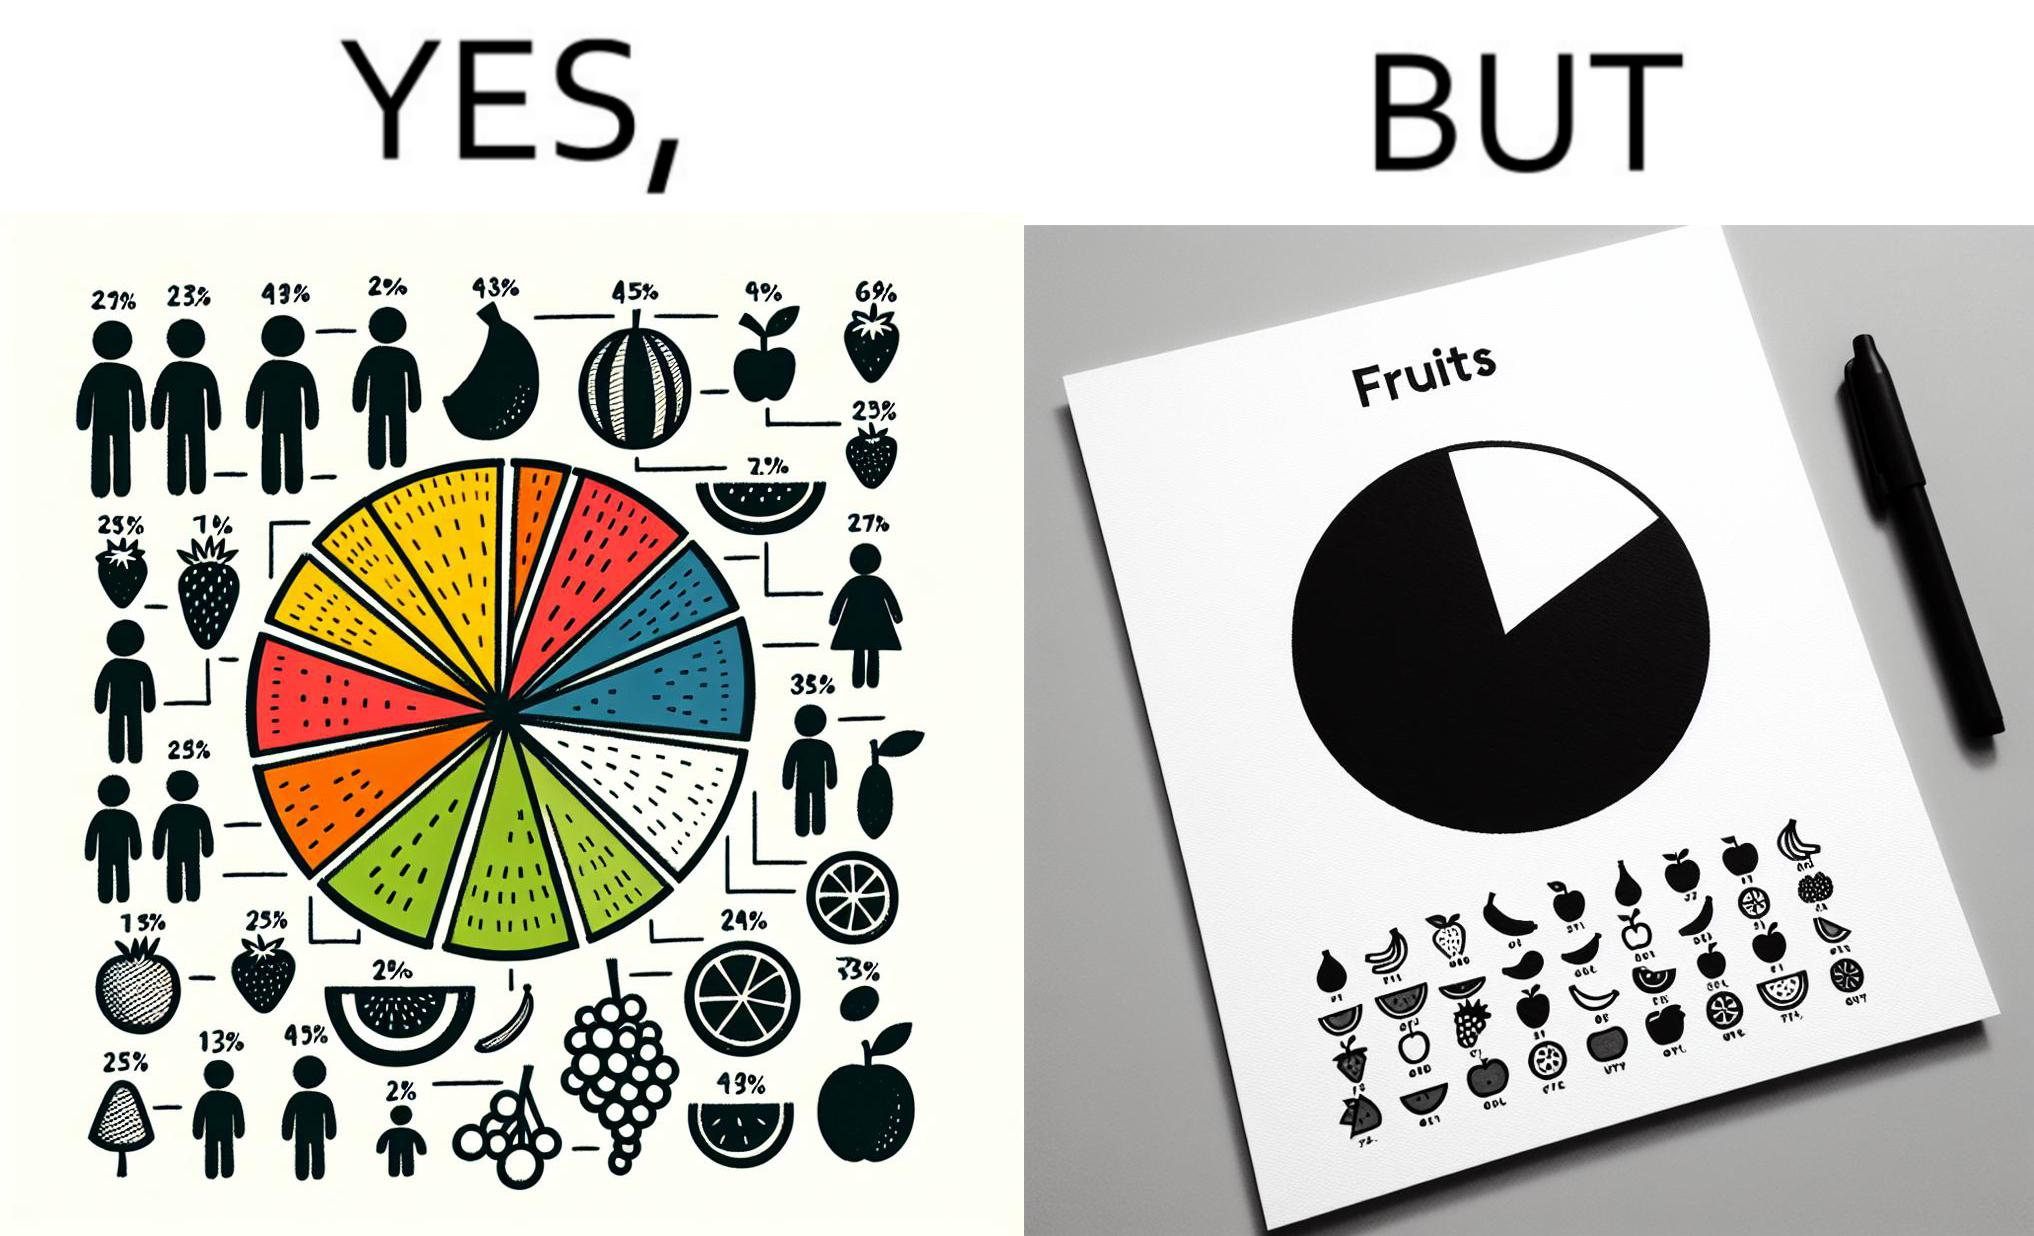What does this image depict? This is funny because the pie chart printout is useless as you cant see any divisions on it because the  printer could not capture the different colors 